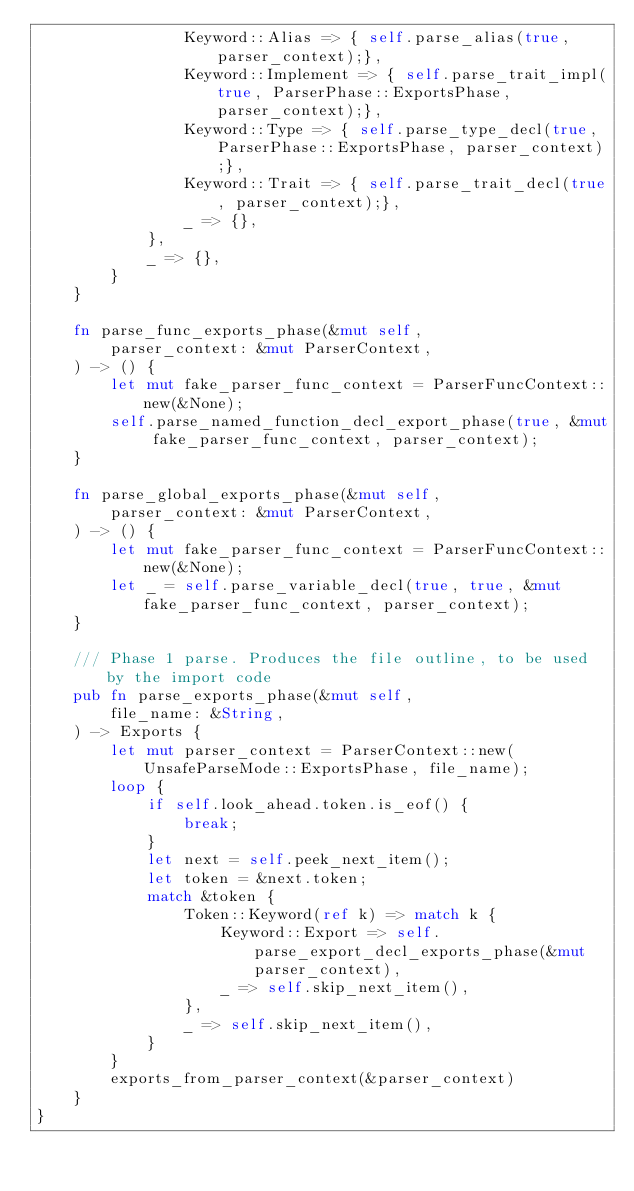Convert code to text. <code><loc_0><loc_0><loc_500><loc_500><_Rust_>                Keyword::Alias => { self.parse_alias(true, parser_context);},
                Keyword::Implement => { self.parse_trait_impl(true, ParserPhase::ExportsPhase, parser_context);},
                Keyword::Type => { self.parse_type_decl(true, ParserPhase::ExportsPhase, parser_context);},
                Keyword::Trait => { self.parse_trait_decl(true, parser_context);},
                _ => {},
            },
            _ => {},
        }
    }
    
    fn parse_func_exports_phase(&mut self,
        parser_context: &mut ParserContext,
    ) -> () {
        let mut fake_parser_func_context = ParserFuncContext::new(&None);
        self.parse_named_function_decl_export_phase(true, &mut fake_parser_func_context, parser_context);
    }

    fn parse_global_exports_phase(&mut self,
        parser_context: &mut ParserContext,
    ) -> () {
        let mut fake_parser_func_context = ParserFuncContext::new(&None);
        let _ = self.parse_variable_decl(true, true, &mut fake_parser_func_context, parser_context);
    }

    /// Phase 1 parse. Produces the file outline, to be used by the import code
    pub fn parse_exports_phase(&mut self, 
        file_name: &String,
    ) -> Exports {
        let mut parser_context = ParserContext::new(UnsafeParseMode::ExportsPhase, file_name);
        loop {
            if self.look_ahead.token.is_eof() {
                break;
            }
            let next = self.peek_next_item();
            let token = &next.token;
            match &token {
                Token::Keyword(ref k) => match k {
                    Keyword::Export => self.parse_export_decl_exports_phase(&mut parser_context),
                    _ => self.skip_next_item(),
                },
                _ => self.skip_next_item(),
            }
        }
        exports_from_parser_context(&parser_context)
    }
}</code> 